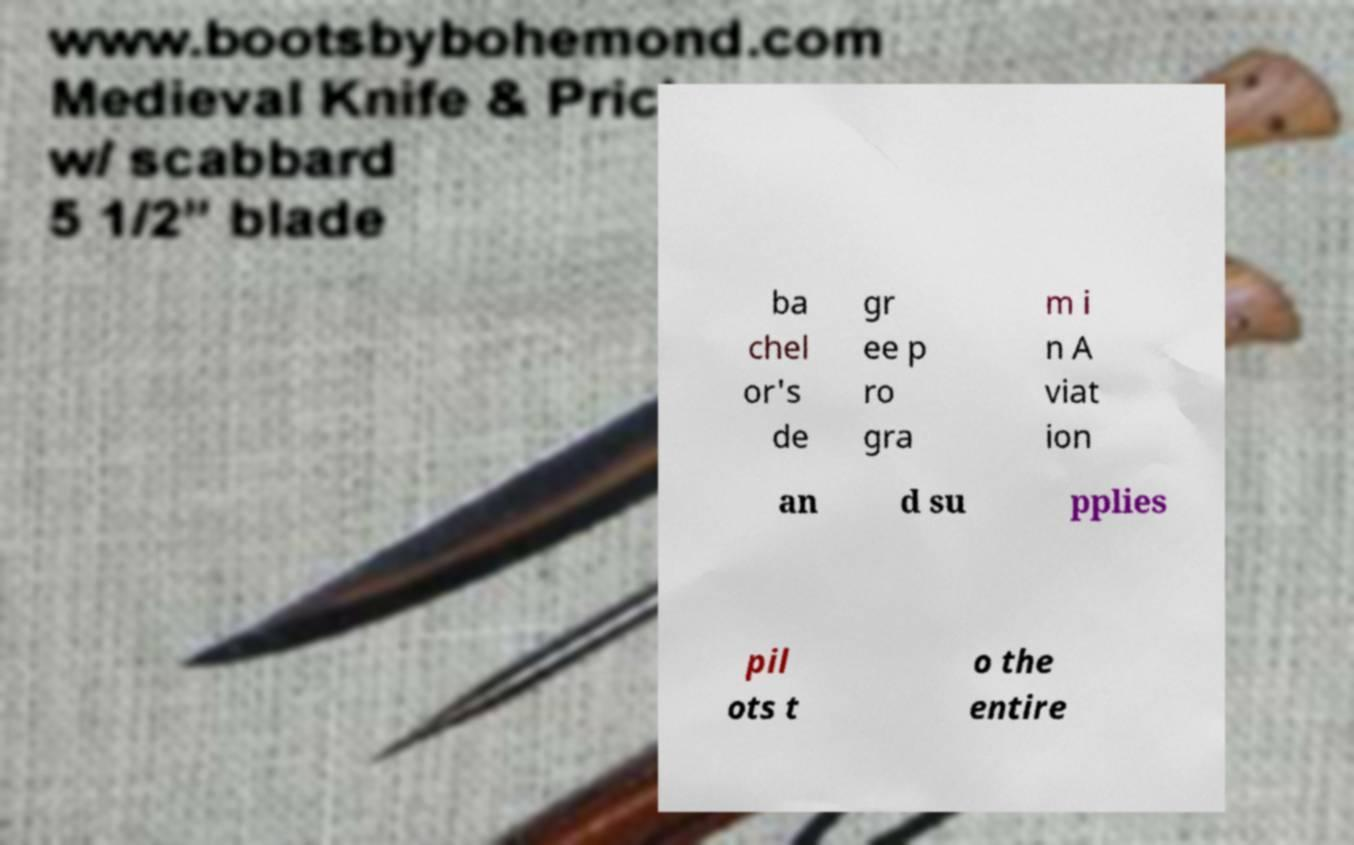I need the written content from this picture converted into text. Can you do that? ba chel or's de gr ee p ro gra m i n A viat ion an d su pplies pil ots t o the entire 